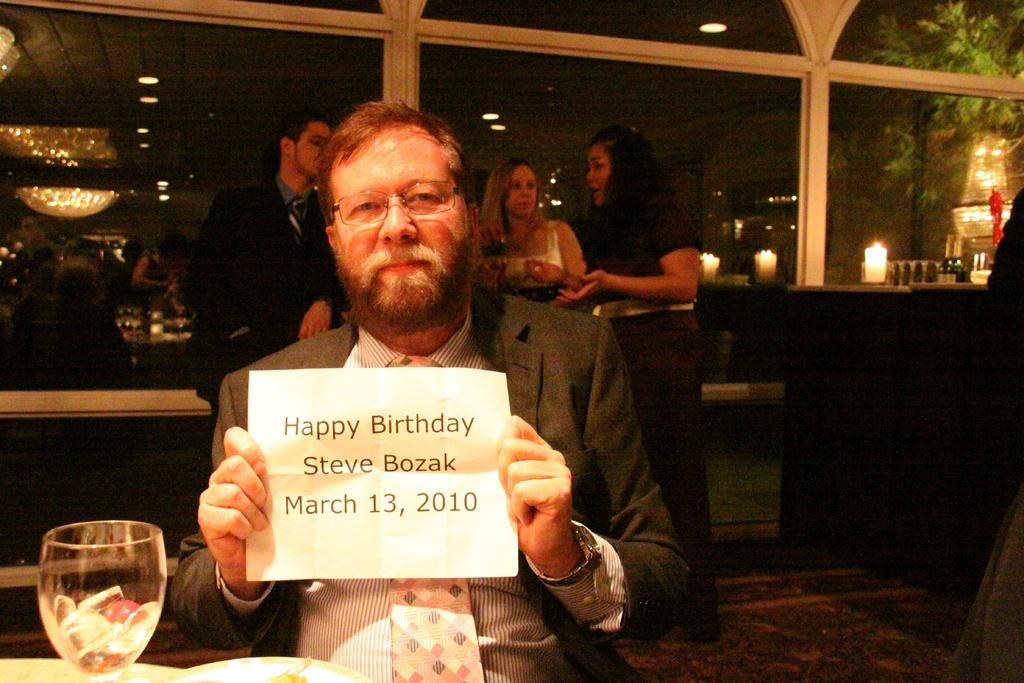In one or two sentences, can you explain what this image depicts? In this image I can see a man in the front and I can see he is holding a white colour paper. I can also see he is wearing formal dress, a watch, a specs and on the paper I can see something is written. In the front of him I can see a glass and in the glass I can see few ice cubes. In the background I can see few more people, few candles, a tree and number of lights on the ceiling. On the right side of this image I can see a bottle and a red colour thing. 